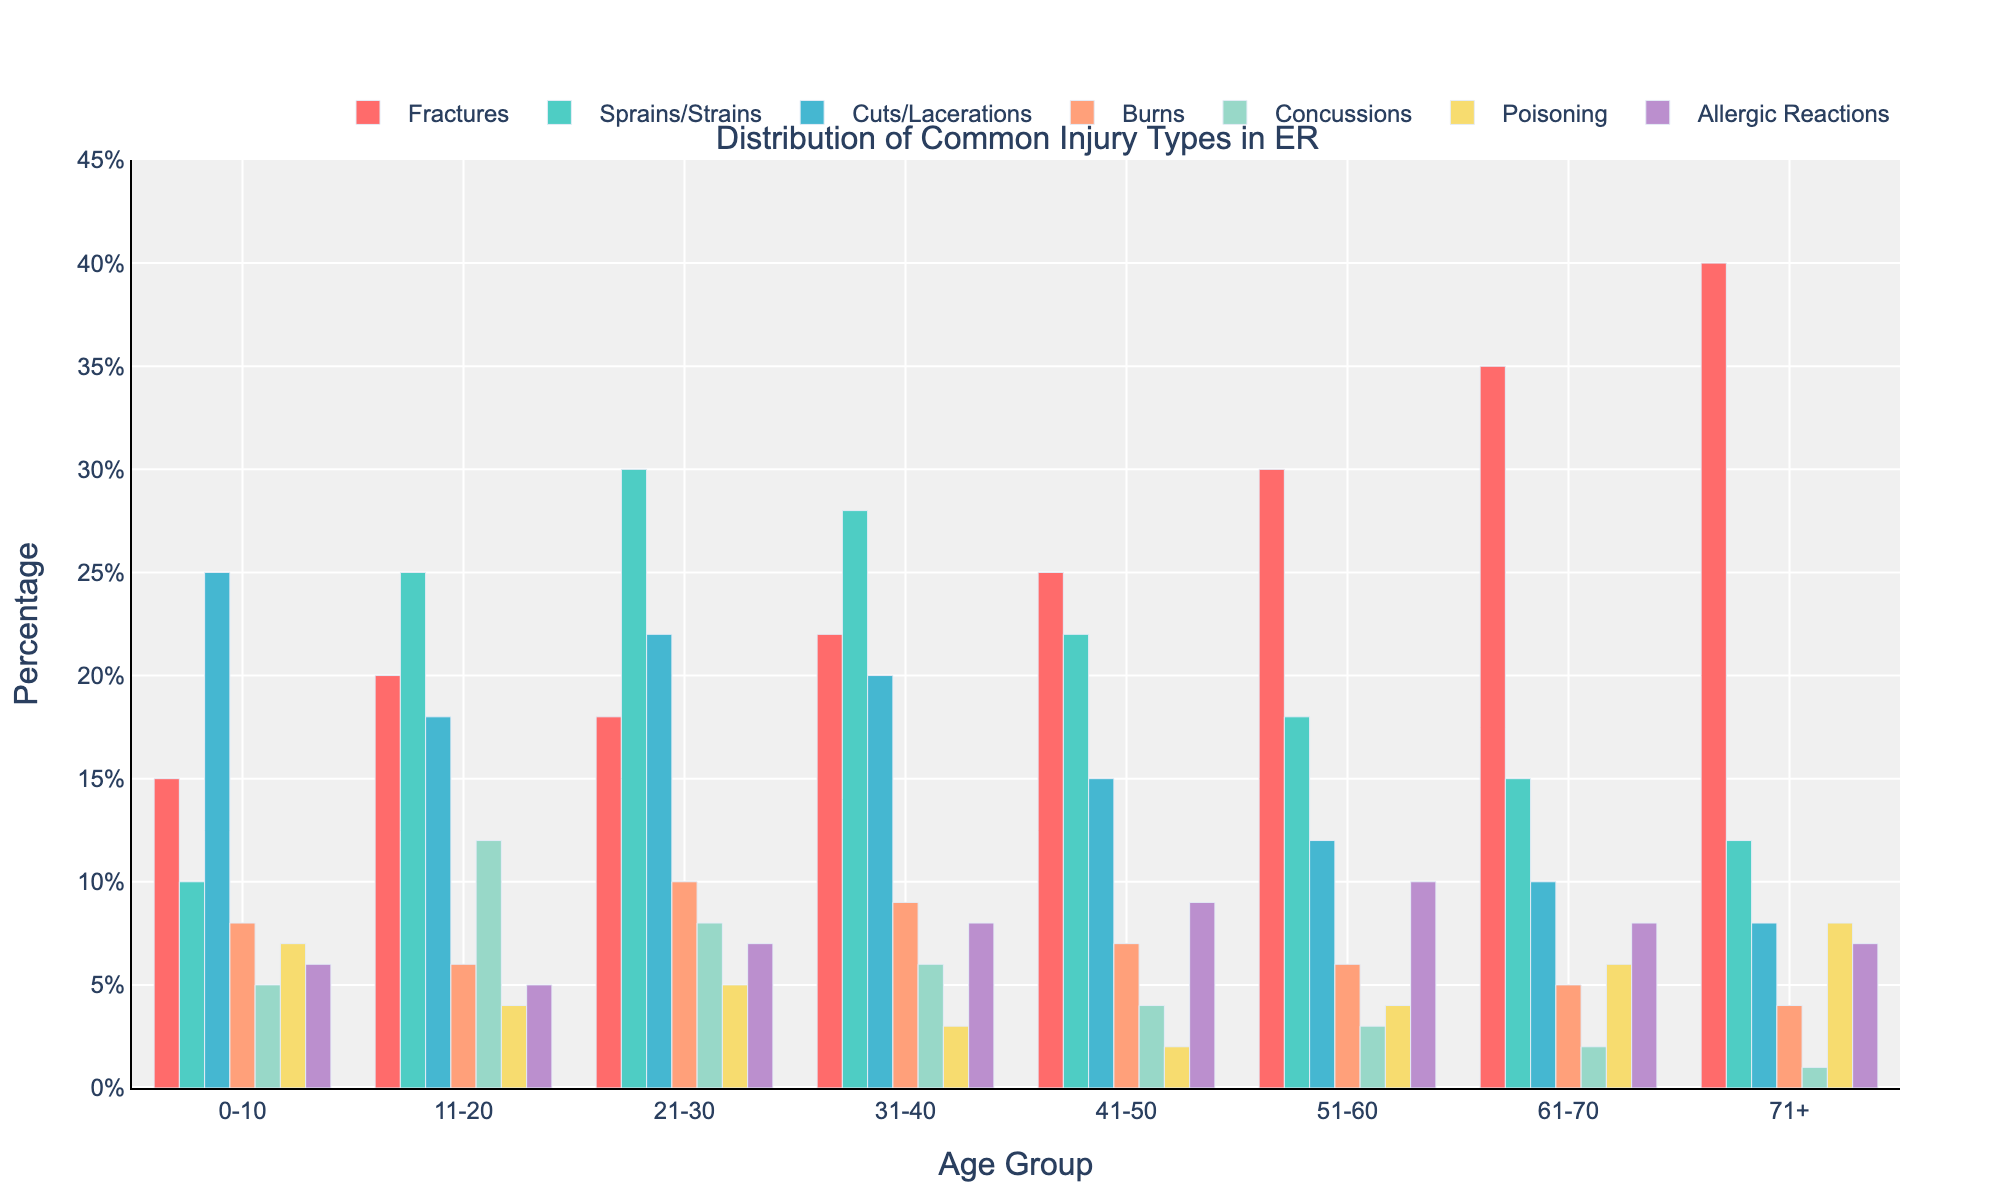What's the most common injury type in the 0-10 age group? The highest bar in the 0-10 age group is for "Cuts/Lacerations" with a value of 25%.
Answer: Cuts/Lacerations Which age group has the highest number of fractures? The "Fractures" bar for the 71+ age group is the highest, indicating the highest number of fractures, at 40%.
Answer: 71+ How does the percentage of burns in the 41-50 age group compare to the 61-70 age group? The bar for "Burns" in the 41-50 age group is 7%, while in the 61-70 age group, it is 5%. So, the percentage of burns is higher in the 41-50 age group.
Answer: Higher in the 41-50 age group Which injury type shows a decreasing trend across the age groups? By observing the bars for each injury type across different age groups, it is clear that "Sprains/Strains" shows a decreasing trend, starting from 10% in the 0-10 age group and gradually decreasing to 12% in the 71+ age group.
Answer: Sprains/Strains What is the sum of percentages for poisoning injuries in the 41-50 and 51-60 age groups? The percentage for "Poisoning" in the 41-50 age group is 2%, and in the 51-60 age group, it is 4%. The sum is 2% + 4% = 6%.
Answer: 6% How many age groups have a higher percentage of concussions than burns? Comparing the percentages of "Concussions" to "Burns" across all age groups: 
- 0-10: Concussions (5%) > Burns (8%) - False
- 11-20: Concussions (12%) > Burns (6%) - True
- 21-30: Concussions (8%) > Burns (10%) - False
- 31-40: Concussions (6%) > Burns (9%) - False
- 41-50: Concussions (4%) > Burns (7%) - False
- 51-60: Concussions (3%) > Burns (6%) - False
- 61-70: Concussions (2%) > Burns (5%) - False
- 71+: Concussions (1%) > Burns (4%) - False
Only one age group (11-20) has a higher percentage of concussions than burns.
Answer: 1 What is the average percentage of allergic reactions across all age groups? Summing up the allergic reactions percentages: 6% + 5% + 7% + 8% + 9% + 10% + 8% + 7% = 60%. The average is 60% / 8 = 7.5%.
Answer: 7.5% Between the 31-40 and 51-60 age groups, which has a higher percentage of cuts/lacerations, and by how much? The percentage of cuts/lacerations in the 31-40 age group is 20%, and in the 51-60 age group, it is 12%. The difference is 20% - 12% = 8%.
Answer: 31-40 age group by 8% Compare the total percentage for fractures and burns in the 0-10 age group. Which is higher and by how much? In the 0-10 age group, fractures are 15% and burns are 8%. The difference is 15% - 8% = 7%. Fractures have the higher total percentage.
Answer: Fractures by 7% 